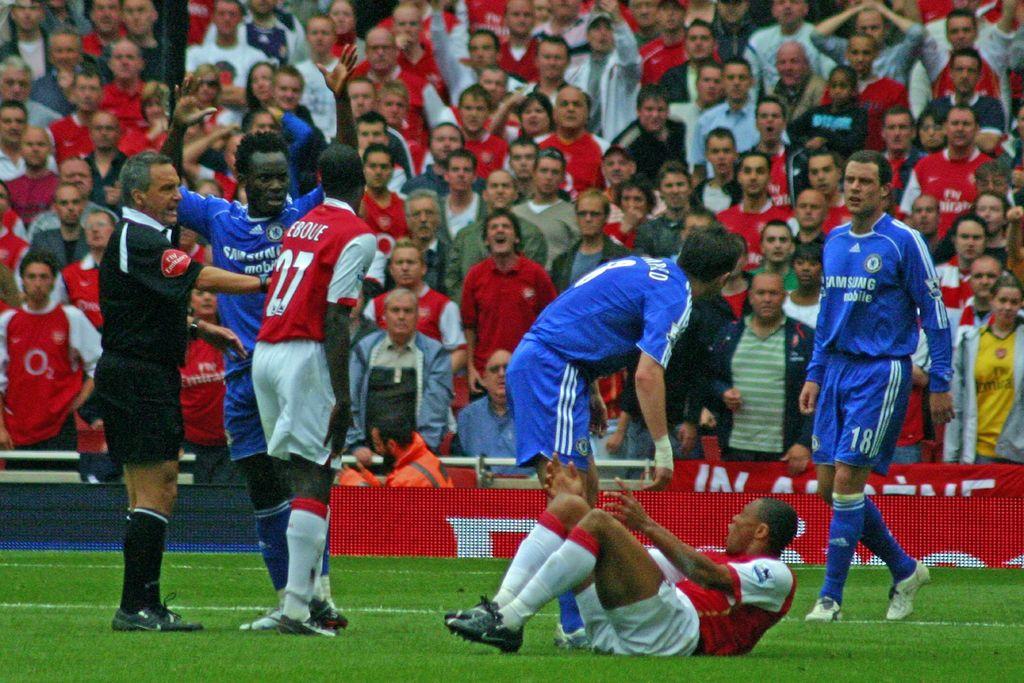What is the number of the red player near the referee?
Ensure brevity in your answer.  27. What brand is advertised on the blue jerserys?
Offer a terse response. Samsung. 